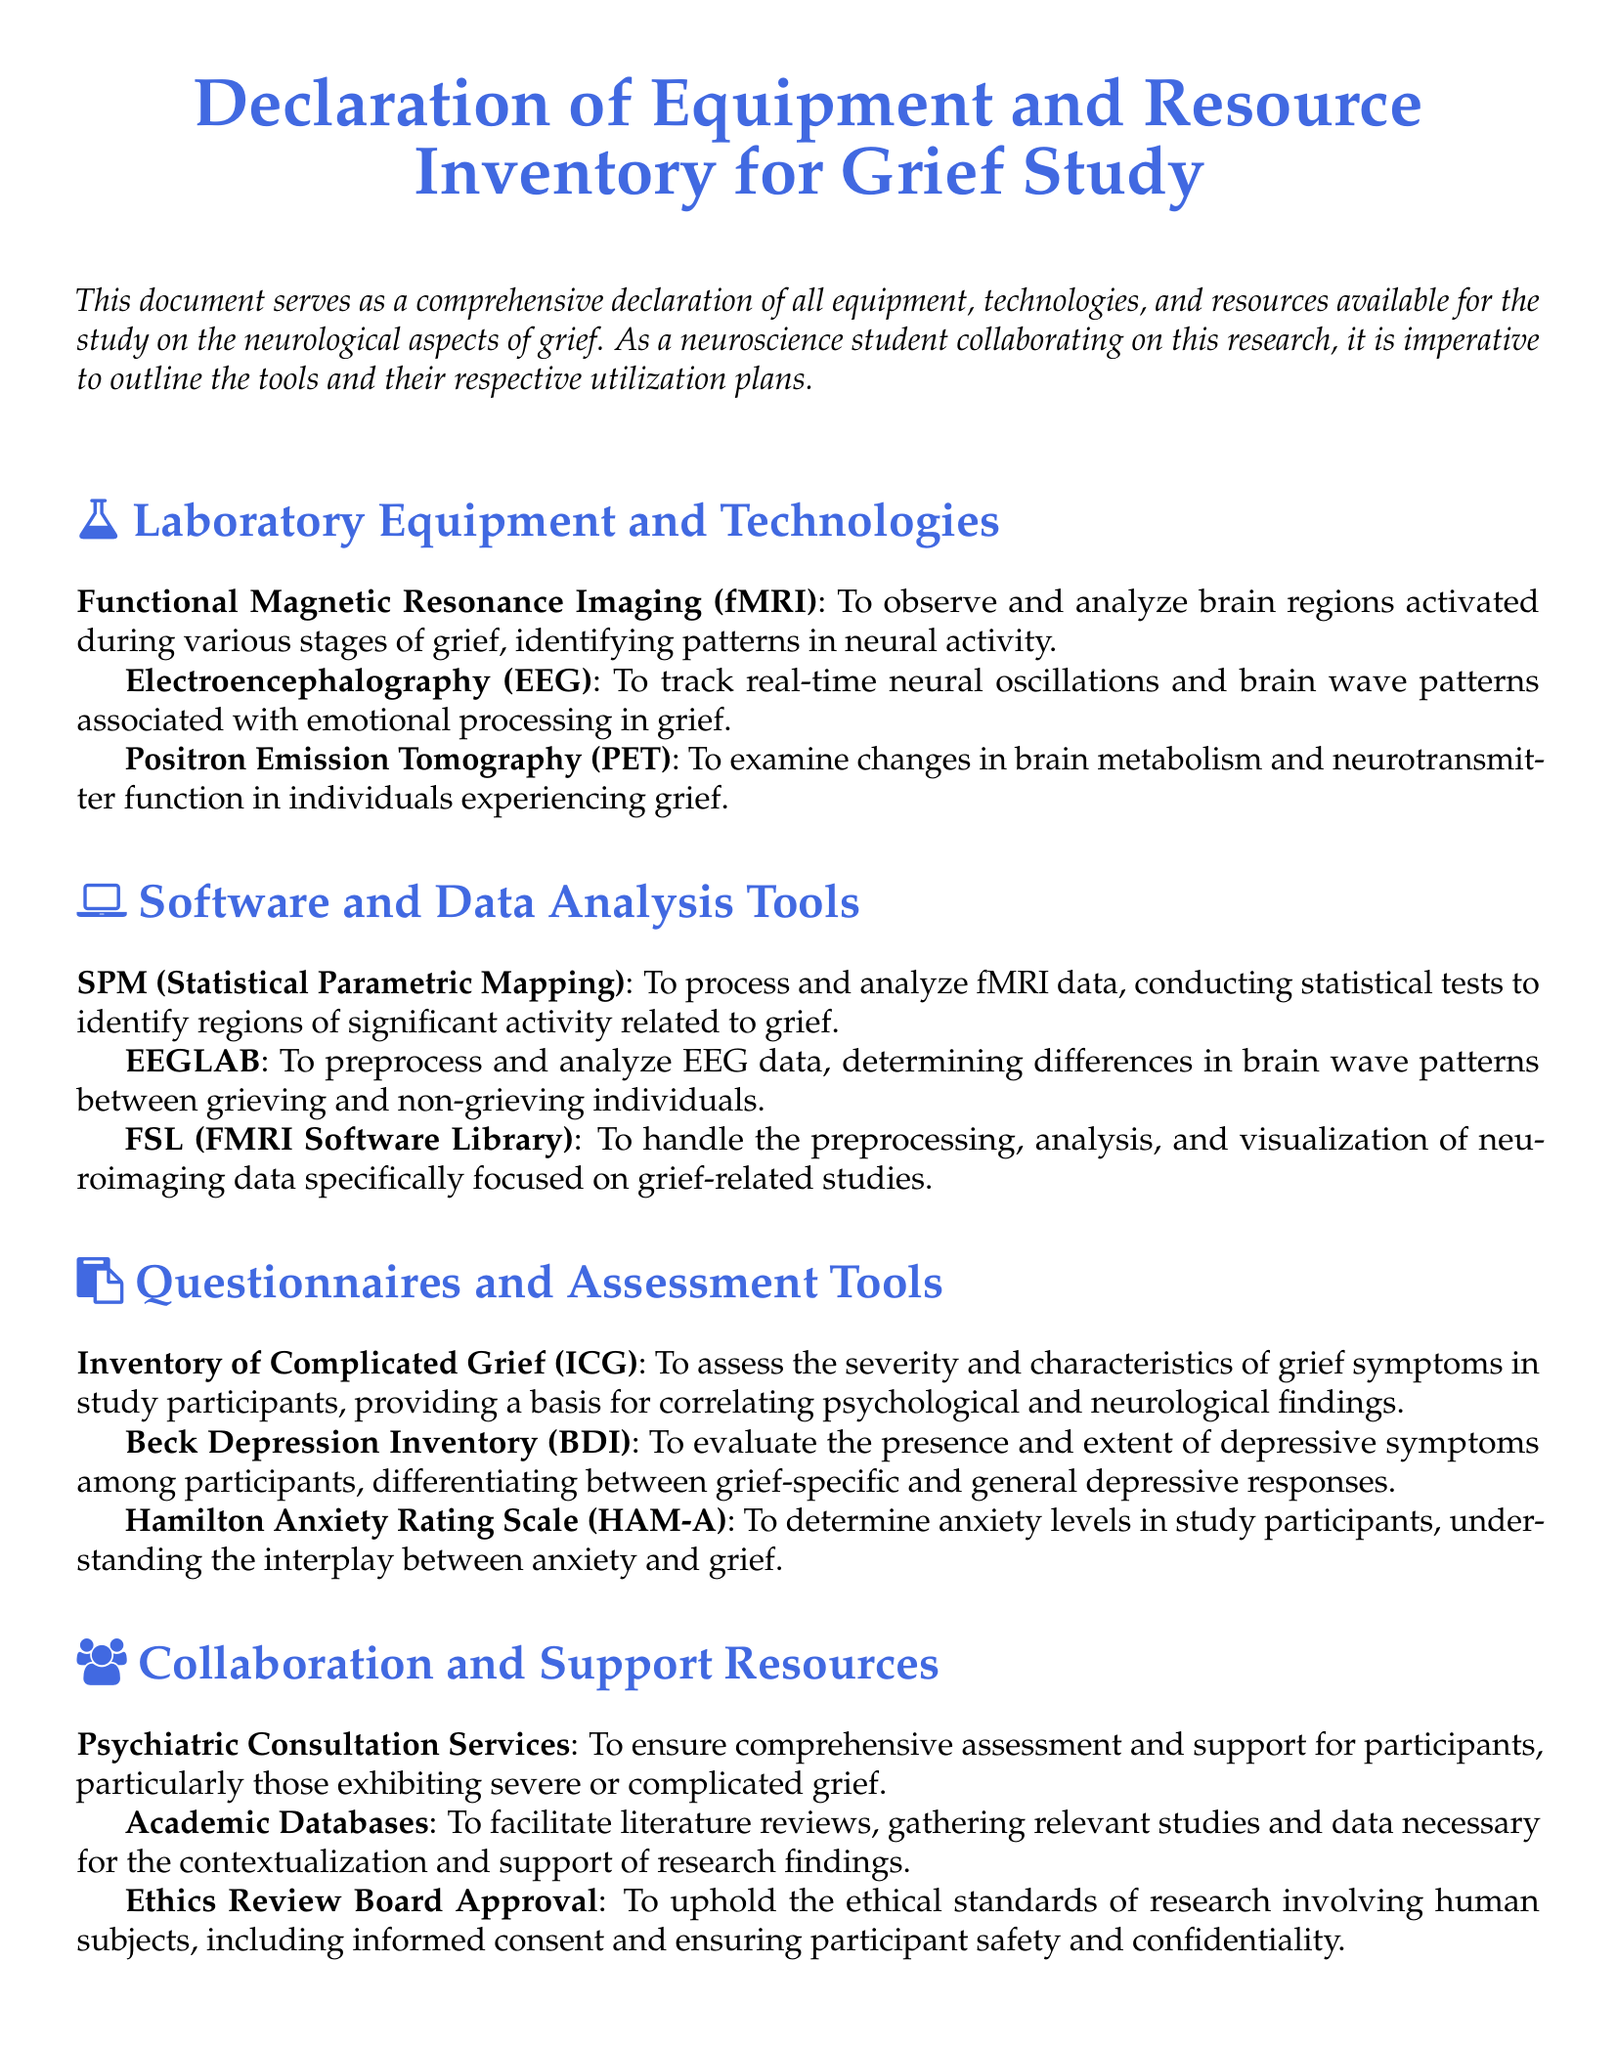What equipment is used to observe brain regions activated during grief? The document lists Functional Magnetic Resonance Imaging (fMRI) as the equipment for observing and analyzing brain regions activated during various stages of grief.
Answer: Functional Magnetic Resonance Imaging (fMRI) What software is used to process fMRI data? The document specifies SPM (Statistical Parametric Mapping) as the software for processing and analyzing fMRI data.
Answer: SPM (Statistical Parametric Mapping) Which questionnaire assesses the severity of grief symptoms? The Inventory of Complicated Grief (ICG) is mentioned in the document as the tool to assess the severity and characteristics of grief symptoms.
Answer: Inventory of Complicated Grief (ICG) What is the primary function of the Ethics Review Board Approval? The document states that it upholds ethical standards of research involving human subjects, ensuring informed consent and participant safety and confidentiality.
Answer: Uphold ethical standards How many tools are listed under Laboratory Equipment and Technologies? The document enumerates three tools available under this section: fMRI, EEG, and PET.
Answer: Three What type of analysis does EEGLAB perform? The document describes EEGLAB as a tool to preprocess and analyze EEG data, focusing on brain wave patterns.
Answer: Preprocess and analyze EEG data What is the purpose of the Beck Depression Inventory (BDI)? The document states that BDI evaluates the presence and extent of depressive symptoms among participants.
Answer: Evaluate depressive symptoms What is utilized to track real-time neural oscillations? The document lists Electroencephalography (EEG) as the tool used to track real-time neural oscillations and brain wave patterns.
Answer: Electroencephalography (EEG) What type of services are provided by Psychiatric Consultation Services? The document mentions that these services ensure comprehensive assessment and support for participants with severe or complicated grief.
Answer: Comprehensive assessment and support 